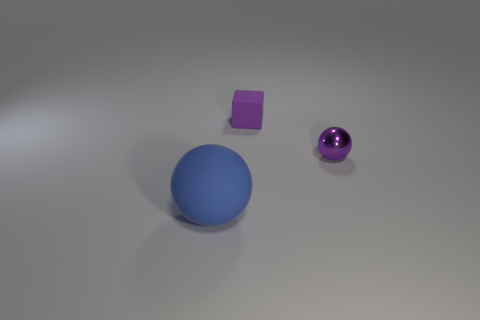Are there any other things that have the same size as the blue object?
Give a very brief answer. No. How many objects are spheres that are on the right side of the blue rubber thing or big blue things?
Make the answer very short. 2. Are there the same number of large rubber balls that are in front of the large matte object and small metal spheres that are on the left side of the small purple matte block?
Keep it short and to the point. Yes. How many other things are there of the same shape as the big object?
Offer a very short reply. 1. Does the sphere right of the blue object have the same size as the blue matte thing left of the purple rubber object?
Offer a very short reply. No. What number of cylinders are either purple things or small rubber things?
Offer a very short reply. 0. How many metal objects are either purple blocks or small gray balls?
Keep it short and to the point. 0. There is another blue object that is the same shape as the tiny metal thing; what is its size?
Provide a succinct answer. Large. Does the purple matte thing have the same size as the purple object right of the small cube?
Your answer should be compact. Yes. What is the shape of the object to the left of the purple rubber cube?
Your answer should be very brief. Sphere. 